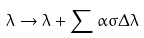<formula> <loc_0><loc_0><loc_500><loc_500>\lambda \rightarrow \lambda + \sum \alpha \sigma \Delta \lambda</formula> 